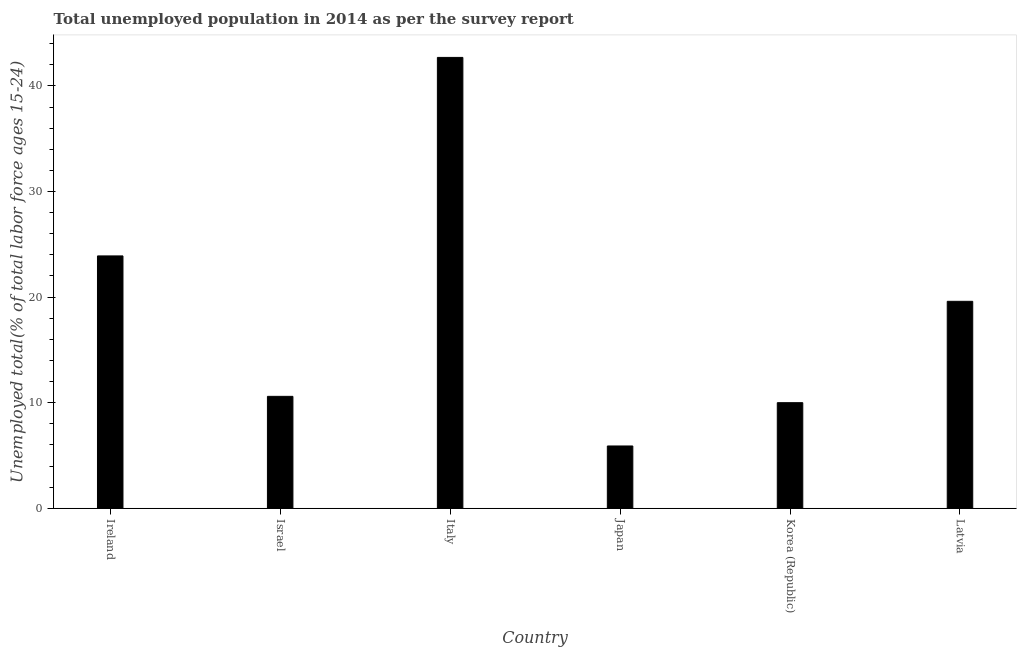Does the graph contain any zero values?
Make the answer very short. No. Does the graph contain grids?
Your answer should be compact. No. What is the title of the graph?
Your response must be concise. Total unemployed population in 2014 as per the survey report. What is the label or title of the Y-axis?
Offer a terse response. Unemployed total(% of total labor force ages 15-24). What is the unemployed youth in Korea (Republic)?
Give a very brief answer. 10. Across all countries, what is the maximum unemployed youth?
Your answer should be compact. 42.7. Across all countries, what is the minimum unemployed youth?
Make the answer very short. 5.9. In which country was the unemployed youth maximum?
Your answer should be very brief. Italy. What is the sum of the unemployed youth?
Your response must be concise. 112.7. What is the difference between the unemployed youth in Italy and Japan?
Provide a succinct answer. 36.8. What is the average unemployed youth per country?
Your answer should be very brief. 18.78. What is the median unemployed youth?
Provide a succinct answer. 15.1. What is the ratio of the unemployed youth in Israel to that in Korea (Republic)?
Offer a terse response. 1.06. Is the difference between the unemployed youth in Italy and Korea (Republic) greater than the difference between any two countries?
Offer a terse response. No. Is the sum of the unemployed youth in Ireland and Japan greater than the maximum unemployed youth across all countries?
Your answer should be compact. No. What is the difference between the highest and the lowest unemployed youth?
Make the answer very short. 36.8. How many countries are there in the graph?
Make the answer very short. 6. What is the difference between two consecutive major ticks on the Y-axis?
Offer a terse response. 10. What is the Unemployed total(% of total labor force ages 15-24) of Ireland?
Your answer should be very brief. 23.9. What is the Unemployed total(% of total labor force ages 15-24) in Israel?
Provide a short and direct response. 10.6. What is the Unemployed total(% of total labor force ages 15-24) of Italy?
Your answer should be compact. 42.7. What is the Unemployed total(% of total labor force ages 15-24) of Japan?
Make the answer very short. 5.9. What is the Unemployed total(% of total labor force ages 15-24) in Latvia?
Your answer should be compact. 19.6. What is the difference between the Unemployed total(% of total labor force ages 15-24) in Ireland and Israel?
Make the answer very short. 13.3. What is the difference between the Unemployed total(% of total labor force ages 15-24) in Ireland and Italy?
Your response must be concise. -18.8. What is the difference between the Unemployed total(% of total labor force ages 15-24) in Ireland and Japan?
Make the answer very short. 18. What is the difference between the Unemployed total(% of total labor force ages 15-24) in Ireland and Latvia?
Your answer should be very brief. 4.3. What is the difference between the Unemployed total(% of total labor force ages 15-24) in Israel and Italy?
Your response must be concise. -32.1. What is the difference between the Unemployed total(% of total labor force ages 15-24) in Israel and Latvia?
Offer a very short reply. -9. What is the difference between the Unemployed total(% of total labor force ages 15-24) in Italy and Japan?
Make the answer very short. 36.8. What is the difference between the Unemployed total(% of total labor force ages 15-24) in Italy and Korea (Republic)?
Provide a succinct answer. 32.7. What is the difference between the Unemployed total(% of total labor force ages 15-24) in Italy and Latvia?
Give a very brief answer. 23.1. What is the difference between the Unemployed total(% of total labor force ages 15-24) in Japan and Korea (Republic)?
Offer a terse response. -4.1. What is the difference between the Unemployed total(% of total labor force ages 15-24) in Japan and Latvia?
Provide a succinct answer. -13.7. What is the difference between the Unemployed total(% of total labor force ages 15-24) in Korea (Republic) and Latvia?
Keep it short and to the point. -9.6. What is the ratio of the Unemployed total(% of total labor force ages 15-24) in Ireland to that in Israel?
Your answer should be compact. 2.25. What is the ratio of the Unemployed total(% of total labor force ages 15-24) in Ireland to that in Italy?
Keep it short and to the point. 0.56. What is the ratio of the Unemployed total(% of total labor force ages 15-24) in Ireland to that in Japan?
Ensure brevity in your answer.  4.05. What is the ratio of the Unemployed total(% of total labor force ages 15-24) in Ireland to that in Korea (Republic)?
Your answer should be compact. 2.39. What is the ratio of the Unemployed total(% of total labor force ages 15-24) in Ireland to that in Latvia?
Ensure brevity in your answer.  1.22. What is the ratio of the Unemployed total(% of total labor force ages 15-24) in Israel to that in Italy?
Make the answer very short. 0.25. What is the ratio of the Unemployed total(% of total labor force ages 15-24) in Israel to that in Japan?
Offer a very short reply. 1.8. What is the ratio of the Unemployed total(% of total labor force ages 15-24) in Israel to that in Korea (Republic)?
Give a very brief answer. 1.06. What is the ratio of the Unemployed total(% of total labor force ages 15-24) in Israel to that in Latvia?
Offer a terse response. 0.54. What is the ratio of the Unemployed total(% of total labor force ages 15-24) in Italy to that in Japan?
Provide a succinct answer. 7.24. What is the ratio of the Unemployed total(% of total labor force ages 15-24) in Italy to that in Korea (Republic)?
Give a very brief answer. 4.27. What is the ratio of the Unemployed total(% of total labor force ages 15-24) in Italy to that in Latvia?
Provide a succinct answer. 2.18. What is the ratio of the Unemployed total(% of total labor force ages 15-24) in Japan to that in Korea (Republic)?
Your response must be concise. 0.59. What is the ratio of the Unemployed total(% of total labor force ages 15-24) in Japan to that in Latvia?
Your answer should be compact. 0.3. What is the ratio of the Unemployed total(% of total labor force ages 15-24) in Korea (Republic) to that in Latvia?
Your answer should be compact. 0.51. 